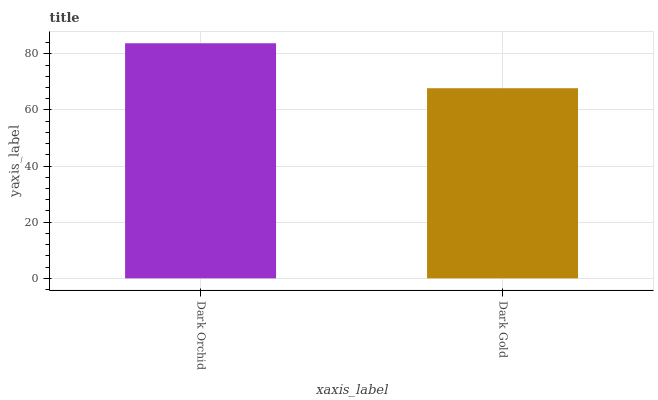Is Dark Gold the maximum?
Answer yes or no. No. Is Dark Orchid greater than Dark Gold?
Answer yes or no. Yes. Is Dark Gold less than Dark Orchid?
Answer yes or no. Yes. Is Dark Gold greater than Dark Orchid?
Answer yes or no. No. Is Dark Orchid less than Dark Gold?
Answer yes or no. No. Is Dark Orchid the high median?
Answer yes or no. Yes. Is Dark Gold the low median?
Answer yes or no. Yes. Is Dark Gold the high median?
Answer yes or no. No. Is Dark Orchid the low median?
Answer yes or no. No. 